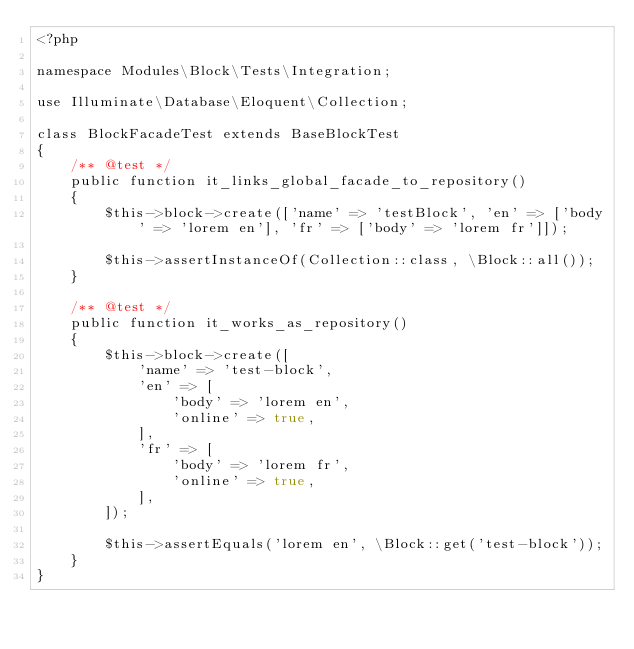Convert code to text. <code><loc_0><loc_0><loc_500><loc_500><_PHP_><?php

namespace Modules\Block\Tests\Integration;

use Illuminate\Database\Eloquent\Collection;

class BlockFacadeTest extends BaseBlockTest
{
    /** @test */
    public function it_links_global_facade_to_repository()
    {
        $this->block->create(['name' => 'testBlock', 'en' => ['body' => 'lorem en'], 'fr' => ['body' => 'lorem fr']]);

        $this->assertInstanceOf(Collection::class, \Block::all());
    }

    /** @test */
    public function it_works_as_repository()
    {
        $this->block->create([
            'name' => 'test-block',
            'en' => [
                'body' => 'lorem en',
                'online' => true,
            ],
            'fr' => [
                'body' => 'lorem fr',
                'online' => true,
            ],
        ]);

        $this->assertEquals('lorem en', \Block::get('test-block'));
    }
}
</code> 